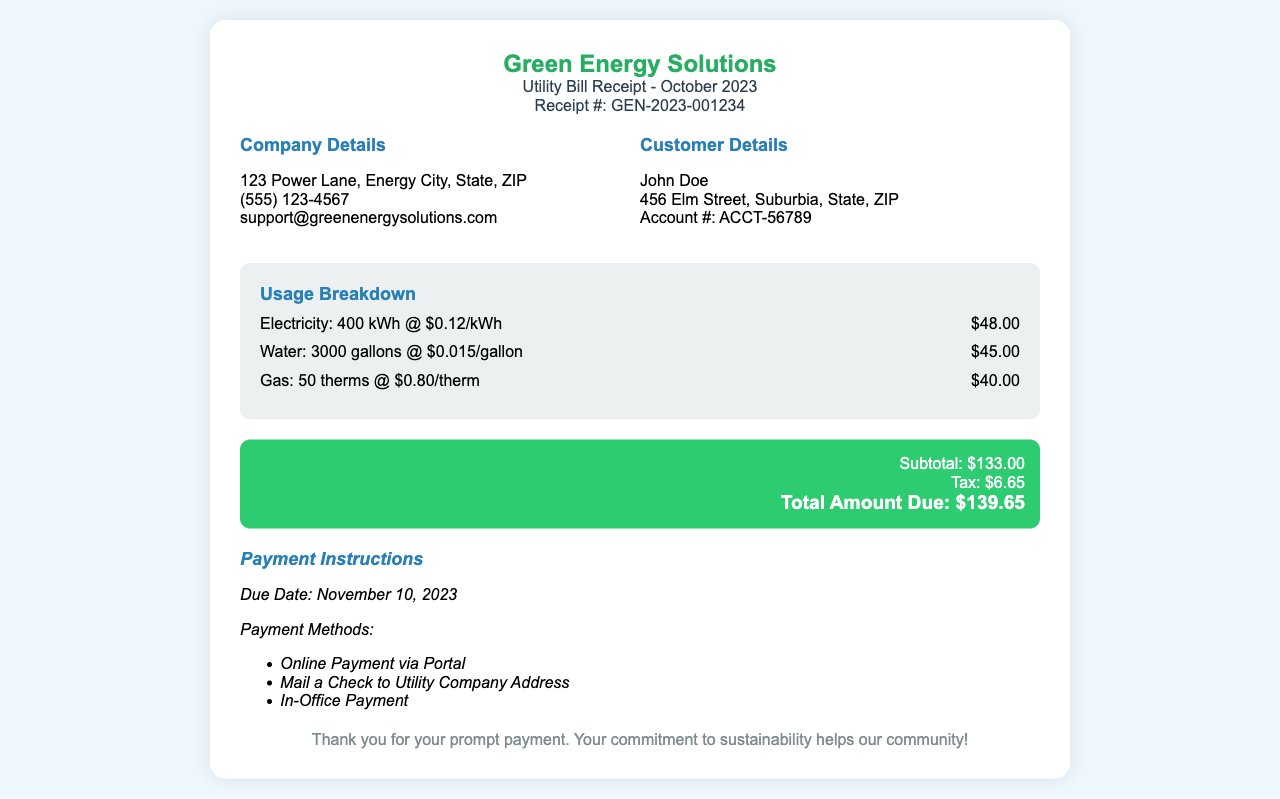What is the company name? The company name is located in the header of the receipt.
Answer: Green Energy Solutions What is the total amount due? The total amount due is indicated in the receipt's total section.
Answer: $139.65 How much is the electricity charge? The electricity charge is detailed in the usage breakdown section.
Answer: $48.00 What is the due date for the payment? The due date is mentioned in the payment instructions section.
Answer: November 10, 2023 How many gallons of water were used? The gallons of water used are specified in the usage breakdown section.
Answer: 3000 gallons What is the tax amount? The tax amount is part of the total due section in the document.
Answer: $6.65 What is the account number? The account number is included in the customer details section.
Answer: ACCT-56789 What is the rate per therm for gas? The rate per therm for gas is given in the usage breakdown section.
Answer: $0.80/therm How many therms of gas were used? The number of therms of gas used can be found in the usage breakdown.
Answer: 50 therms 